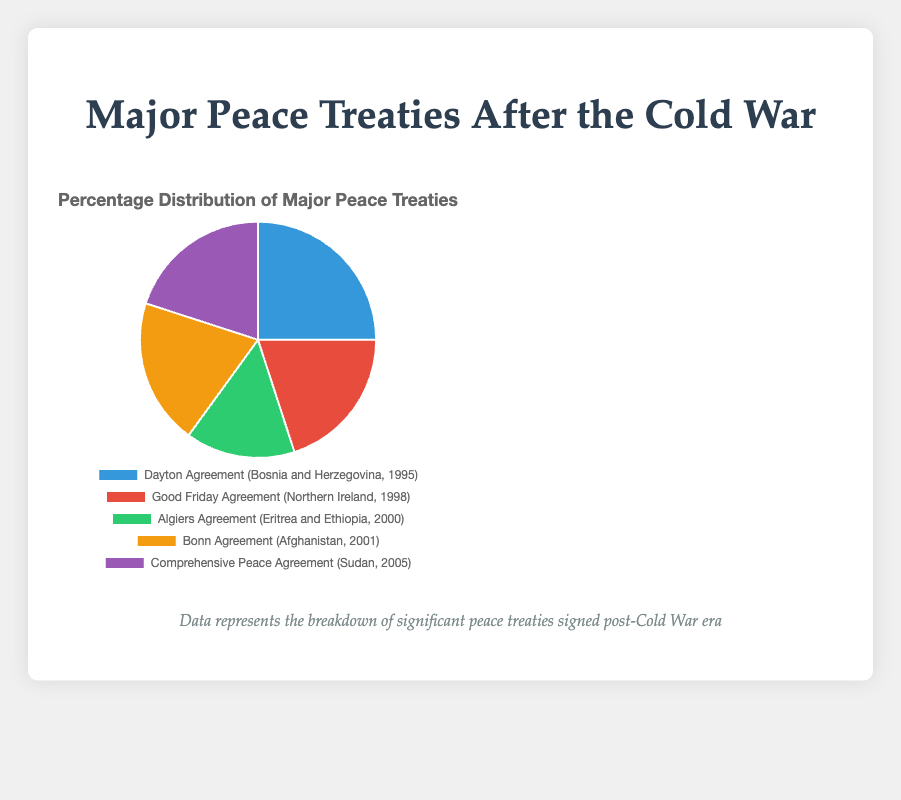what is the most significant peace treaty based on distribution? The Dayton Agreement in Bosnia and Herzegovina has the highest percentage (25%) in the pie chart.
Answer: Dayton Agreement Which two peace treaties have equal percentages? The Good Friday Agreement, the Bonn Agreement, and the Comprehensive Peace Agreement each constitute 20% of the total distribution.
Answer: Good Friday Agreement, Bonn Agreement, and Comprehensive Peace Agreement How much larger is the percentage of the Dayton Agreement compared to the Algiers Agreement? The Dayton Agreement is 25% and the Algiers Agreement is 15%. The difference is 25% - 15% = 10%.
Answer: 10% Which region does the Treaty associated with the lowest percentage cover? The Algiers Agreement, which is associated with the lowest percentage (15%), covers the region of Eritrea and Ethiopia.
Answer: Eritrea and Ethiopia Calculate the total percentage covered by the treaties signed before 2000? The Dayton Agreement (25%) and Good Friday Agreement (20%) are the treaties signed before 2000. Their combined percentage is 25% + 20% = 45%.
Answer: 45% What is the combined percentage of treaties involving African countries? The Algiers Agreement (15%) and Comprehensive Peace Agreement (20%) involve African countries. Summing these, (15% + 20% = 35%).
Answer: 35% Which treaty is represented by the green color in the pie chart? The green color represents the Algiers Agreement, with a 15% distribution.
Answer: Algiers Agreement 